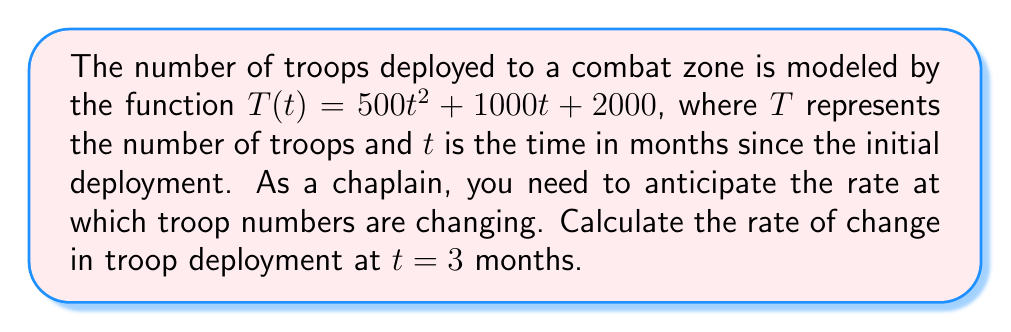Can you answer this question? To find the rate of change in troop deployment, we need to calculate the derivative of the given function $T(t)$ and then evaluate it at $t = 3$.

Step 1: Find the derivative of $T(t)$.
$$T(t) = 500t^2 + 1000t + 2000$$
$$T'(t) = 1000t + 1000$$

Step 2: Evaluate $T'(t)$ at $t = 3$.
$$T'(3) = 1000(3) + 1000$$
$$T'(3) = 3000 + 1000 = 4000$$

The rate of change at $t = 3$ months is 4000 troops per month. This means that after 3 months, the number of troops is increasing at a rate of 4000 troops per month.

As a chaplain, this information can help you anticipate the growing spiritual and emotional support needs of the increasing troop population in the combat zone.
Answer: 4000 troops/month 